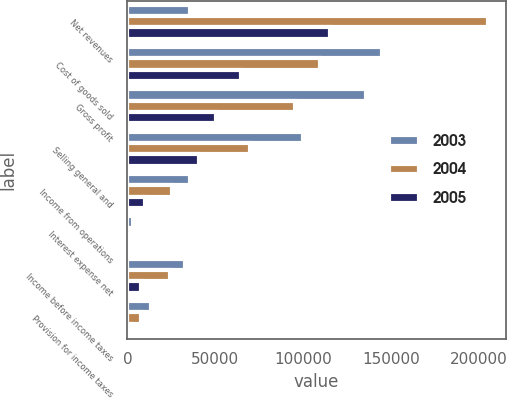Convert chart. <chart><loc_0><loc_0><loc_500><loc_500><stacked_bar_chart><ecel><fcel>Net revenues<fcel>Cost of goods sold<fcel>Gross profit<fcel>Selling general and<fcel>Income from operations<fcel>Interest expense net<fcel>Income before income taxes<fcel>Provision for income taxes<nl><fcel>2003<fcel>35889<fcel>145203<fcel>135850<fcel>99961<fcel>35889<fcel>2915<fcel>32974<fcel>13255<nl><fcel>2004<fcel>205181<fcel>109748<fcel>95433<fcel>70053<fcel>25380<fcel>1284<fcel>24096<fcel>7774<nl><fcel>2005<fcel>115419<fcel>64757<fcel>50662<fcel>40709<fcel>9953<fcel>2214<fcel>7739<fcel>1991<nl></chart> 